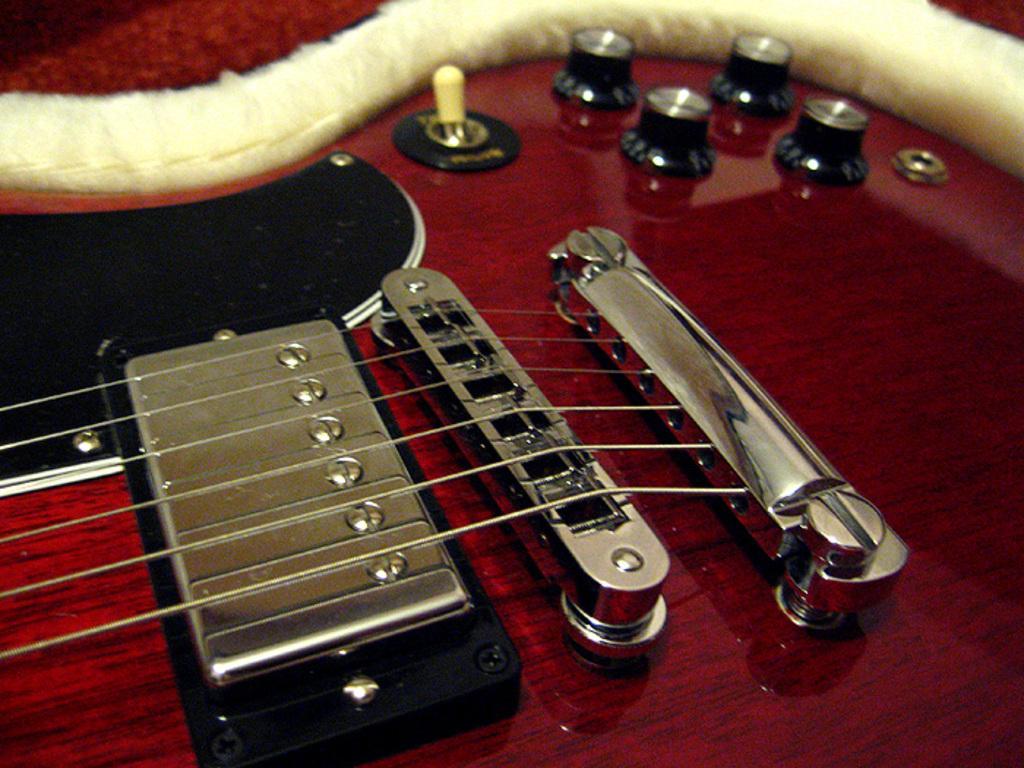How would you summarize this image in a sentence or two? In the center of the image we can see a guitar with strings. 